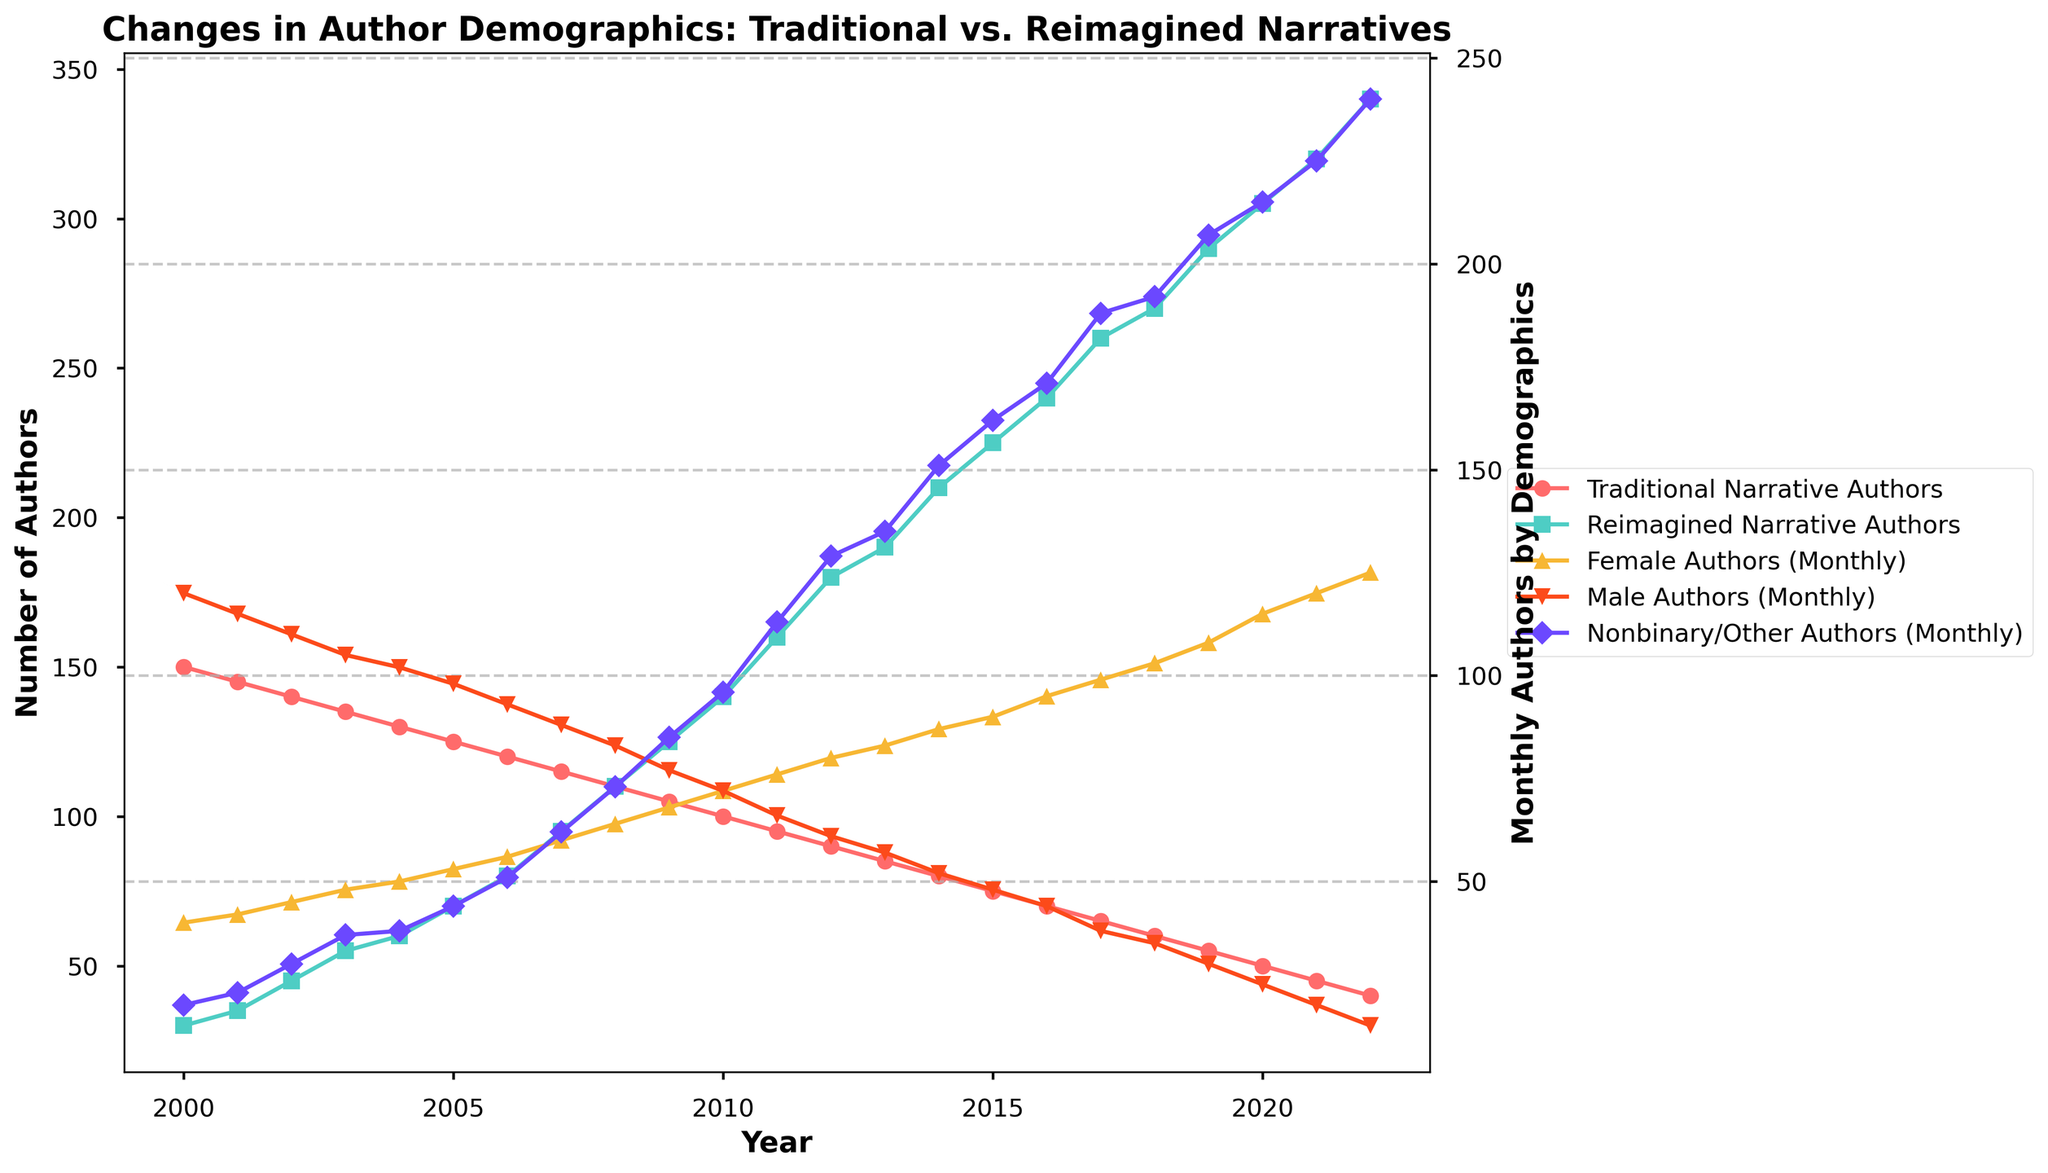What is the title of the figure? The title of the figure is usually located at the top of the plot. In this case, the title reads 'Changes in Author Demographics: Traditional vs. Reimagined Narratives'.
Answer: Changes in Author Demographics: Traditional vs. Reimagined Narratives How does the number of traditional narrative authors change from 2000 to 2022? To get the change in traditional narrative authors from 2000 to 2022, look at the corresponding values in those years. In 2000, there are 150 traditional narrative authors, and by 2022, this number has decreased to 40.
Answer: Decreases from 150 to 40 Which year has the highest number of authors publishing reimagined narratives? Look at the plot line representing reimagined narrative authors (green squares) and identify the highest point. This happens in 2022 with 340 authors.
Answer: 2022 In what year do nonbinary/other authors monthly surpass male authors monthly? Identify the point where the plot line for nonbinary/other authors (purple diamonds) crosses the plot line for male authors (red triangles). This occurs around 2017.
Answer: 2017 What is the trend for female authors' monthly numbers over the years? Observe the trend line for female authors (orange triangles). This line shows a consistent upward trend from 40 in 2000 to 125 in 2022.
Answer: Increasing How do the numbers of male authors change from 2010 to 2020? Refer to the male authors' plot (red triangles) from 2010 to 2020. The value declines from 72 in 2010 to 25 in 2020.
Answer: Decrease from 72 to 25 Between which consecutive years does the number of reimagined narrative authors increase by the largest amount? Calculate the differences in the number of reimagined narrative authors between consecutive years and find the maximum. The largest increase is from 2011 (160) to 2012 (180), a difference of 20 authors.
Answer: Between 2011 and 2012 How many more nonbinary/other authors were there monthly compared to female authors in 2022? Compare the values for nonbinary/other authors and female authors in 2022. There are 240 nonbinary/other authors and 125 female authors, so the difference is 240 - 125 = 115.
Answer: 115 Which demographic has the most authors monthly in 2022? Examine each demographic line for the year 2022. Nonbinary/Other authors have 240, the highest among the demographics.
Answer: Nonbinary/Other authors What is the overall trend for traditional narrative authors? Observe the trend line for traditional narrative authors (red circles). This line shows a consistent downward trend from 150 in 2000 to 40 in 2022.
Answer: Decreasing How many authors in total were publishing reimagined narratives in 2015 and 2018 combined? Look at the reimagined narrative authors' count for 2015 and 2018. Adding these values gives 225 (2015) + 270 (2018) = 495.
Answer: 495 